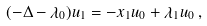<formula> <loc_0><loc_0><loc_500><loc_500>( - \Delta - \lambda _ { 0 } ) u _ { 1 } = - x _ { 1 } u _ { 0 } + \lambda _ { 1 } u _ { 0 } \, ,</formula> 